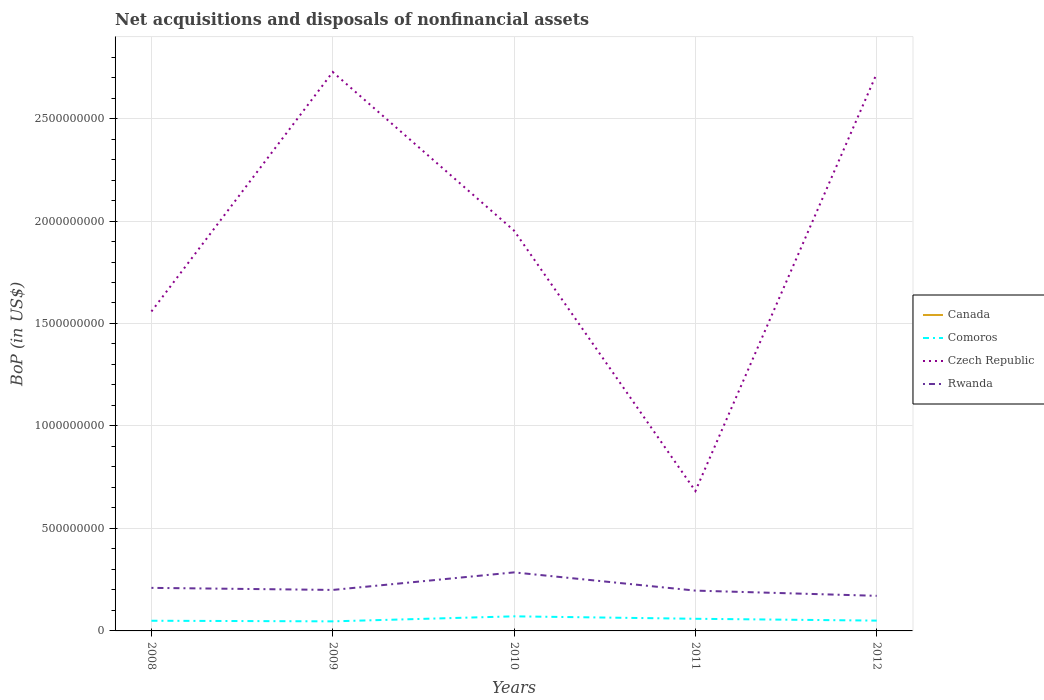Is the number of lines equal to the number of legend labels?
Keep it short and to the point. No. Across all years, what is the maximum Balance of Payments in Rwanda?
Offer a very short reply. 1.71e+08. What is the total Balance of Payments in Comoros in the graph?
Your answer should be compact. 8.97e+06. What is the difference between the highest and the second highest Balance of Payments in Czech Republic?
Provide a succinct answer. 2.04e+09. Is the Balance of Payments in Comoros strictly greater than the Balance of Payments in Rwanda over the years?
Provide a succinct answer. Yes. What is the difference between two consecutive major ticks on the Y-axis?
Provide a short and direct response. 5.00e+08. Does the graph contain any zero values?
Provide a short and direct response. Yes. Does the graph contain grids?
Offer a very short reply. Yes. How many legend labels are there?
Make the answer very short. 4. How are the legend labels stacked?
Keep it short and to the point. Vertical. What is the title of the graph?
Your answer should be compact. Net acquisitions and disposals of nonfinancial assets. What is the label or title of the Y-axis?
Give a very brief answer. BoP (in US$). What is the BoP (in US$) in Comoros in 2008?
Provide a short and direct response. 4.97e+07. What is the BoP (in US$) of Czech Republic in 2008?
Give a very brief answer. 1.56e+09. What is the BoP (in US$) of Rwanda in 2008?
Provide a succinct answer. 2.10e+08. What is the BoP (in US$) of Comoros in 2009?
Keep it short and to the point. 4.67e+07. What is the BoP (in US$) of Czech Republic in 2009?
Your answer should be very brief. 2.73e+09. What is the BoP (in US$) in Canada in 2010?
Ensure brevity in your answer.  0. What is the BoP (in US$) in Comoros in 2010?
Keep it short and to the point. 7.12e+07. What is the BoP (in US$) in Czech Republic in 2010?
Offer a terse response. 1.95e+09. What is the BoP (in US$) in Rwanda in 2010?
Offer a terse response. 2.86e+08. What is the BoP (in US$) of Comoros in 2011?
Your response must be concise. 5.93e+07. What is the BoP (in US$) of Czech Republic in 2011?
Give a very brief answer. 6.83e+08. What is the BoP (in US$) of Rwanda in 2011?
Provide a succinct answer. 1.97e+08. What is the BoP (in US$) in Canada in 2012?
Give a very brief answer. 0. What is the BoP (in US$) of Comoros in 2012?
Ensure brevity in your answer.  5.03e+07. What is the BoP (in US$) in Czech Republic in 2012?
Provide a succinct answer. 2.72e+09. What is the BoP (in US$) of Rwanda in 2012?
Provide a short and direct response. 1.71e+08. Across all years, what is the maximum BoP (in US$) of Comoros?
Your answer should be very brief. 7.12e+07. Across all years, what is the maximum BoP (in US$) of Czech Republic?
Provide a succinct answer. 2.73e+09. Across all years, what is the maximum BoP (in US$) in Rwanda?
Provide a short and direct response. 2.86e+08. Across all years, what is the minimum BoP (in US$) in Comoros?
Keep it short and to the point. 4.67e+07. Across all years, what is the minimum BoP (in US$) of Czech Republic?
Make the answer very short. 6.83e+08. Across all years, what is the minimum BoP (in US$) of Rwanda?
Keep it short and to the point. 1.71e+08. What is the total BoP (in US$) in Canada in the graph?
Offer a very short reply. 0. What is the total BoP (in US$) in Comoros in the graph?
Provide a short and direct response. 2.77e+08. What is the total BoP (in US$) of Czech Republic in the graph?
Your answer should be very brief. 9.64e+09. What is the total BoP (in US$) of Rwanda in the graph?
Your response must be concise. 1.06e+09. What is the difference between the BoP (in US$) in Comoros in 2008 and that in 2009?
Offer a very short reply. 2.97e+06. What is the difference between the BoP (in US$) of Czech Republic in 2008 and that in 2009?
Your answer should be compact. -1.17e+09. What is the difference between the BoP (in US$) of Rwanda in 2008 and that in 2009?
Offer a very short reply. 1.01e+07. What is the difference between the BoP (in US$) in Comoros in 2008 and that in 2010?
Provide a short and direct response. -2.15e+07. What is the difference between the BoP (in US$) of Czech Republic in 2008 and that in 2010?
Provide a short and direct response. -3.94e+08. What is the difference between the BoP (in US$) of Rwanda in 2008 and that in 2010?
Ensure brevity in your answer.  -7.56e+07. What is the difference between the BoP (in US$) of Comoros in 2008 and that in 2011?
Your answer should be very brief. -9.60e+06. What is the difference between the BoP (in US$) in Czech Republic in 2008 and that in 2011?
Make the answer very short. 8.76e+08. What is the difference between the BoP (in US$) of Rwanda in 2008 and that in 2011?
Ensure brevity in your answer.  1.34e+07. What is the difference between the BoP (in US$) of Comoros in 2008 and that in 2012?
Offer a terse response. -6.36e+05. What is the difference between the BoP (in US$) in Czech Republic in 2008 and that in 2012?
Give a very brief answer. -1.16e+09. What is the difference between the BoP (in US$) in Rwanda in 2008 and that in 2012?
Provide a short and direct response. 3.88e+07. What is the difference between the BoP (in US$) of Comoros in 2009 and that in 2010?
Your answer should be compact. -2.45e+07. What is the difference between the BoP (in US$) of Czech Republic in 2009 and that in 2010?
Your answer should be very brief. 7.74e+08. What is the difference between the BoP (in US$) of Rwanda in 2009 and that in 2010?
Provide a succinct answer. -8.56e+07. What is the difference between the BoP (in US$) in Comoros in 2009 and that in 2011?
Ensure brevity in your answer.  -1.26e+07. What is the difference between the BoP (in US$) of Czech Republic in 2009 and that in 2011?
Your answer should be compact. 2.04e+09. What is the difference between the BoP (in US$) in Rwanda in 2009 and that in 2011?
Provide a short and direct response. 3.34e+06. What is the difference between the BoP (in US$) of Comoros in 2009 and that in 2012?
Provide a short and direct response. -3.61e+06. What is the difference between the BoP (in US$) in Czech Republic in 2009 and that in 2012?
Provide a short and direct response. 7.45e+06. What is the difference between the BoP (in US$) in Rwanda in 2009 and that in 2012?
Keep it short and to the point. 2.88e+07. What is the difference between the BoP (in US$) of Comoros in 2010 and that in 2011?
Offer a terse response. 1.19e+07. What is the difference between the BoP (in US$) in Czech Republic in 2010 and that in 2011?
Make the answer very short. 1.27e+09. What is the difference between the BoP (in US$) in Rwanda in 2010 and that in 2011?
Make the answer very short. 8.90e+07. What is the difference between the BoP (in US$) in Comoros in 2010 and that in 2012?
Keep it short and to the point. 2.09e+07. What is the difference between the BoP (in US$) in Czech Republic in 2010 and that in 2012?
Offer a very short reply. -7.66e+08. What is the difference between the BoP (in US$) in Rwanda in 2010 and that in 2012?
Your response must be concise. 1.14e+08. What is the difference between the BoP (in US$) of Comoros in 2011 and that in 2012?
Make the answer very short. 8.97e+06. What is the difference between the BoP (in US$) in Czech Republic in 2011 and that in 2012?
Provide a succinct answer. -2.04e+09. What is the difference between the BoP (in US$) in Rwanda in 2011 and that in 2012?
Provide a succinct answer. 2.54e+07. What is the difference between the BoP (in US$) of Comoros in 2008 and the BoP (in US$) of Czech Republic in 2009?
Your response must be concise. -2.68e+09. What is the difference between the BoP (in US$) of Comoros in 2008 and the BoP (in US$) of Rwanda in 2009?
Offer a terse response. -1.50e+08. What is the difference between the BoP (in US$) of Czech Republic in 2008 and the BoP (in US$) of Rwanda in 2009?
Keep it short and to the point. 1.36e+09. What is the difference between the BoP (in US$) in Comoros in 2008 and the BoP (in US$) in Czech Republic in 2010?
Your answer should be very brief. -1.90e+09. What is the difference between the BoP (in US$) of Comoros in 2008 and the BoP (in US$) of Rwanda in 2010?
Provide a succinct answer. -2.36e+08. What is the difference between the BoP (in US$) in Czech Republic in 2008 and the BoP (in US$) in Rwanda in 2010?
Make the answer very short. 1.27e+09. What is the difference between the BoP (in US$) in Comoros in 2008 and the BoP (in US$) in Czech Republic in 2011?
Ensure brevity in your answer.  -6.33e+08. What is the difference between the BoP (in US$) of Comoros in 2008 and the BoP (in US$) of Rwanda in 2011?
Keep it short and to the point. -1.47e+08. What is the difference between the BoP (in US$) of Czech Republic in 2008 and the BoP (in US$) of Rwanda in 2011?
Offer a terse response. 1.36e+09. What is the difference between the BoP (in US$) in Comoros in 2008 and the BoP (in US$) in Czech Republic in 2012?
Your response must be concise. -2.67e+09. What is the difference between the BoP (in US$) of Comoros in 2008 and the BoP (in US$) of Rwanda in 2012?
Offer a very short reply. -1.22e+08. What is the difference between the BoP (in US$) in Czech Republic in 2008 and the BoP (in US$) in Rwanda in 2012?
Give a very brief answer. 1.39e+09. What is the difference between the BoP (in US$) of Comoros in 2009 and the BoP (in US$) of Czech Republic in 2010?
Provide a short and direct response. -1.91e+09. What is the difference between the BoP (in US$) of Comoros in 2009 and the BoP (in US$) of Rwanda in 2010?
Offer a very short reply. -2.39e+08. What is the difference between the BoP (in US$) of Czech Republic in 2009 and the BoP (in US$) of Rwanda in 2010?
Your answer should be compact. 2.44e+09. What is the difference between the BoP (in US$) of Comoros in 2009 and the BoP (in US$) of Czech Republic in 2011?
Provide a short and direct response. -6.36e+08. What is the difference between the BoP (in US$) of Comoros in 2009 and the BoP (in US$) of Rwanda in 2011?
Keep it short and to the point. -1.50e+08. What is the difference between the BoP (in US$) of Czech Republic in 2009 and the BoP (in US$) of Rwanda in 2011?
Your response must be concise. 2.53e+09. What is the difference between the BoP (in US$) in Comoros in 2009 and the BoP (in US$) in Czech Republic in 2012?
Your response must be concise. -2.67e+09. What is the difference between the BoP (in US$) of Comoros in 2009 and the BoP (in US$) of Rwanda in 2012?
Ensure brevity in your answer.  -1.25e+08. What is the difference between the BoP (in US$) in Czech Republic in 2009 and the BoP (in US$) in Rwanda in 2012?
Provide a short and direct response. 2.56e+09. What is the difference between the BoP (in US$) in Comoros in 2010 and the BoP (in US$) in Czech Republic in 2011?
Your response must be concise. -6.11e+08. What is the difference between the BoP (in US$) of Comoros in 2010 and the BoP (in US$) of Rwanda in 2011?
Your response must be concise. -1.25e+08. What is the difference between the BoP (in US$) of Czech Republic in 2010 and the BoP (in US$) of Rwanda in 2011?
Your answer should be compact. 1.76e+09. What is the difference between the BoP (in US$) in Comoros in 2010 and the BoP (in US$) in Czech Republic in 2012?
Provide a short and direct response. -2.65e+09. What is the difference between the BoP (in US$) in Comoros in 2010 and the BoP (in US$) in Rwanda in 2012?
Make the answer very short. -1.00e+08. What is the difference between the BoP (in US$) in Czech Republic in 2010 and the BoP (in US$) in Rwanda in 2012?
Provide a succinct answer. 1.78e+09. What is the difference between the BoP (in US$) in Comoros in 2011 and the BoP (in US$) in Czech Republic in 2012?
Offer a very short reply. -2.66e+09. What is the difference between the BoP (in US$) in Comoros in 2011 and the BoP (in US$) in Rwanda in 2012?
Make the answer very short. -1.12e+08. What is the difference between the BoP (in US$) in Czech Republic in 2011 and the BoP (in US$) in Rwanda in 2012?
Give a very brief answer. 5.11e+08. What is the average BoP (in US$) in Comoros per year?
Offer a terse response. 5.54e+07. What is the average BoP (in US$) of Czech Republic per year?
Offer a terse response. 1.93e+09. What is the average BoP (in US$) of Rwanda per year?
Keep it short and to the point. 2.13e+08. In the year 2008, what is the difference between the BoP (in US$) of Comoros and BoP (in US$) of Czech Republic?
Your answer should be very brief. -1.51e+09. In the year 2008, what is the difference between the BoP (in US$) in Comoros and BoP (in US$) in Rwanda?
Provide a succinct answer. -1.60e+08. In the year 2008, what is the difference between the BoP (in US$) of Czech Republic and BoP (in US$) of Rwanda?
Offer a terse response. 1.35e+09. In the year 2009, what is the difference between the BoP (in US$) in Comoros and BoP (in US$) in Czech Republic?
Offer a terse response. -2.68e+09. In the year 2009, what is the difference between the BoP (in US$) of Comoros and BoP (in US$) of Rwanda?
Your answer should be very brief. -1.53e+08. In the year 2009, what is the difference between the BoP (in US$) in Czech Republic and BoP (in US$) in Rwanda?
Keep it short and to the point. 2.53e+09. In the year 2010, what is the difference between the BoP (in US$) in Comoros and BoP (in US$) in Czech Republic?
Your answer should be compact. -1.88e+09. In the year 2010, what is the difference between the BoP (in US$) in Comoros and BoP (in US$) in Rwanda?
Offer a terse response. -2.14e+08. In the year 2010, what is the difference between the BoP (in US$) of Czech Republic and BoP (in US$) of Rwanda?
Your answer should be compact. 1.67e+09. In the year 2011, what is the difference between the BoP (in US$) of Comoros and BoP (in US$) of Czech Republic?
Give a very brief answer. -6.23e+08. In the year 2011, what is the difference between the BoP (in US$) of Comoros and BoP (in US$) of Rwanda?
Provide a short and direct response. -1.37e+08. In the year 2011, what is the difference between the BoP (in US$) in Czech Republic and BoP (in US$) in Rwanda?
Provide a succinct answer. 4.86e+08. In the year 2012, what is the difference between the BoP (in US$) of Comoros and BoP (in US$) of Czech Republic?
Provide a short and direct response. -2.67e+09. In the year 2012, what is the difference between the BoP (in US$) in Comoros and BoP (in US$) in Rwanda?
Provide a short and direct response. -1.21e+08. In the year 2012, what is the difference between the BoP (in US$) in Czech Republic and BoP (in US$) in Rwanda?
Your response must be concise. 2.55e+09. What is the ratio of the BoP (in US$) of Comoros in 2008 to that in 2009?
Keep it short and to the point. 1.06. What is the ratio of the BoP (in US$) in Czech Republic in 2008 to that in 2009?
Keep it short and to the point. 0.57. What is the ratio of the BoP (in US$) of Rwanda in 2008 to that in 2009?
Keep it short and to the point. 1.05. What is the ratio of the BoP (in US$) in Comoros in 2008 to that in 2010?
Offer a very short reply. 0.7. What is the ratio of the BoP (in US$) of Czech Republic in 2008 to that in 2010?
Make the answer very short. 0.8. What is the ratio of the BoP (in US$) of Rwanda in 2008 to that in 2010?
Your response must be concise. 0.74. What is the ratio of the BoP (in US$) in Comoros in 2008 to that in 2011?
Provide a succinct answer. 0.84. What is the ratio of the BoP (in US$) in Czech Republic in 2008 to that in 2011?
Your response must be concise. 2.28. What is the ratio of the BoP (in US$) in Rwanda in 2008 to that in 2011?
Offer a very short reply. 1.07. What is the ratio of the BoP (in US$) in Comoros in 2008 to that in 2012?
Offer a terse response. 0.99. What is the ratio of the BoP (in US$) in Czech Republic in 2008 to that in 2012?
Ensure brevity in your answer.  0.57. What is the ratio of the BoP (in US$) in Rwanda in 2008 to that in 2012?
Offer a very short reply. 1.23. What is the ratio of the BoP (in US$) in Comoros in 2009 to that in 2010?
Provide a succinct answer. 0.66. What is the ratio of the BoP (in US$) in Czech Republic in 2009 to that in 2010?
Your answer should be compact. 1.4. What is the ratio of the BoP (in US$) in Rwanda in 2009 to that in 2010?
Your response must be concise. 0.7. What is the ratio of the BoP (in US$) of Comoros in 2009 to that in 2011?
Ensure brevity in your answer.  0.79. What is the ratio of the BoP (in US$) in Czech Republic in 2009 to that in 2011?
Make the answer very short. 4. What is the ratio of the BoP (in US$) of Comoros in 2009 to that in 2012?
Keep it short and to the point. 0.93. What is the ratio of the BoP (in US$) in Czech Republic in 2009 to that in 2012?
Offer a terse response. 1. What is the ratio of the BoP (in US$) in Rwanda in 2009 to that in 2012?
Your answer should be compact. 1.17. What is the ratio of the BoP (in US$) of Comoros in 2010 to that in 2011?
Your answer should be compact. 1.2. What is the ratio of the BoP (in US$) in Czech Republic in 2010 to that in 2011?
Make the answer very short. 2.86. What is the ratio of the BoP (in US$) in Rwanda in 2010 to that in 2011?
Your answer should be very brief. 1.45. What is the ratio of the BoP (in US$) in Comoros in 2010 to that in 2012?
Offer a very short reply. 1.42. What is the ratio of the BoP (in US$) in Czech Republic in 2010 to that in 2012?
Your answer should be compact. 0.72. What is the ratio of the BoP (in US$) of Rwanda in 2010 to that in 2012?
Ensure brevity in your answer.  1.67. What is the ratio of the BoP (in US$) in Comoros in 2011 to that in 2012?
Give a very brief answer. 1.18. What is the ratio of the BoP (in US$) of Czech Republic in 2011 to that in 2012?
Give a very brief answer. 0.25. What is the ratio of the BoP (in US$) of Rwanda in 2011 to that in 2012?
Ensure brevity in your answer.  1.15. What is the difference between the highest and the second highest BoP (in US$) of Comoros?
Provide a succinct answer. 1.19e+07. What is the difference between the highest and the second highest BoP (in US$) in Czech Republic?
Offer a very short reply. 7.45e+06. What is the difference between the highest and the second highest BoP (in US$) in Rwanda?
Provide a succinct answer. 7.56e+07. What is the difference between the highest and the lowest BoP (in US$) of Comoros?
Keep it short and to the point. 2.45e+07. What is the difference between the highest and the lowest BoP (in US$) of Czech Republic?
Provide a succinct answer. 2.04e+09. What is the difference between the highest and the lowest BoP (in US$) in Rwanda?
Make the answer very short. 1.14e+08. 